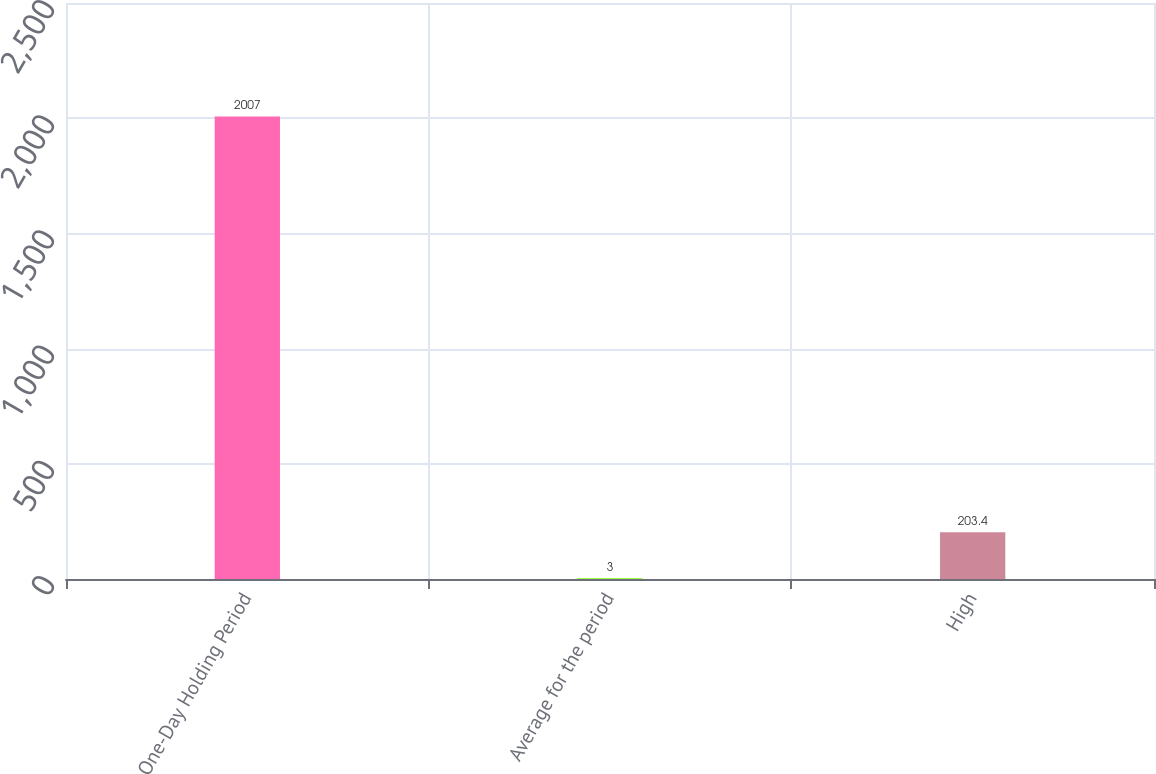Convert chart. <chart><loc_0><loc_0><loc_500><loc_500><bar_chart><fcel>One-Day Holding Period<fcel>Average for the period<fcel>High<nl><fcel>2007<fcel>3<fcel>203.4<nl></chart> 